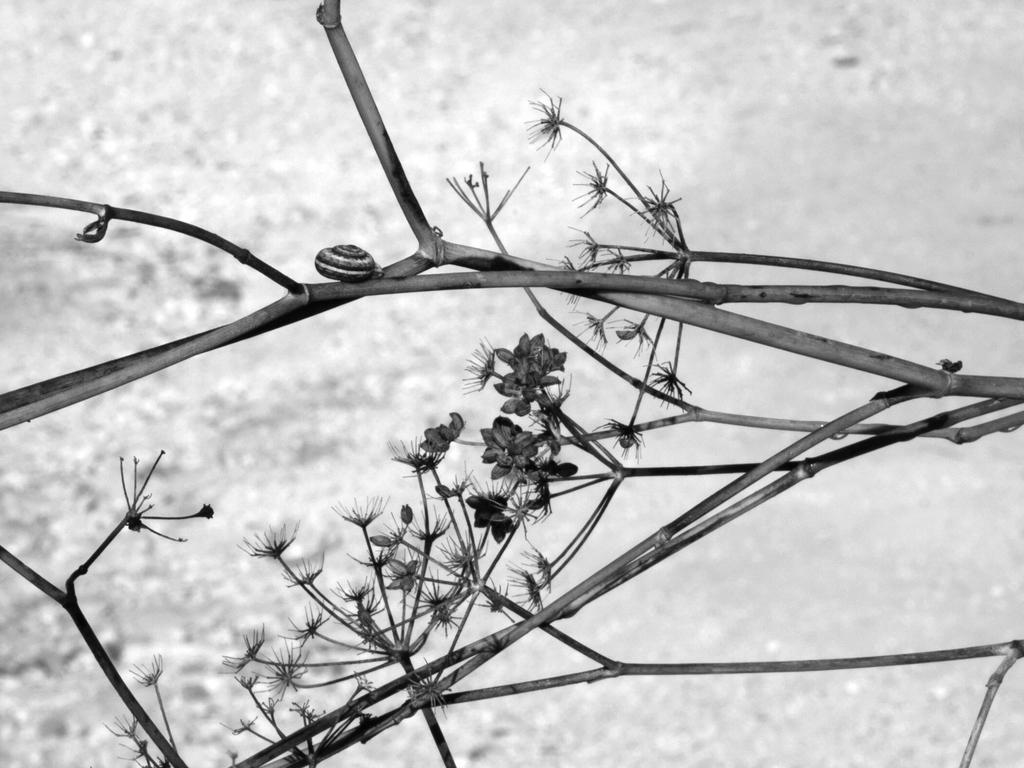What type of plant is depicted in the image? The image contains stems and flowers of a plant. What color scheme is used in the image? The image is black and white. How many feet are visible in the image? There are no feet present in the image; it features a plant with stems and flowers. What type of wheel can be seen in the image? There is no wheel present in the image. 